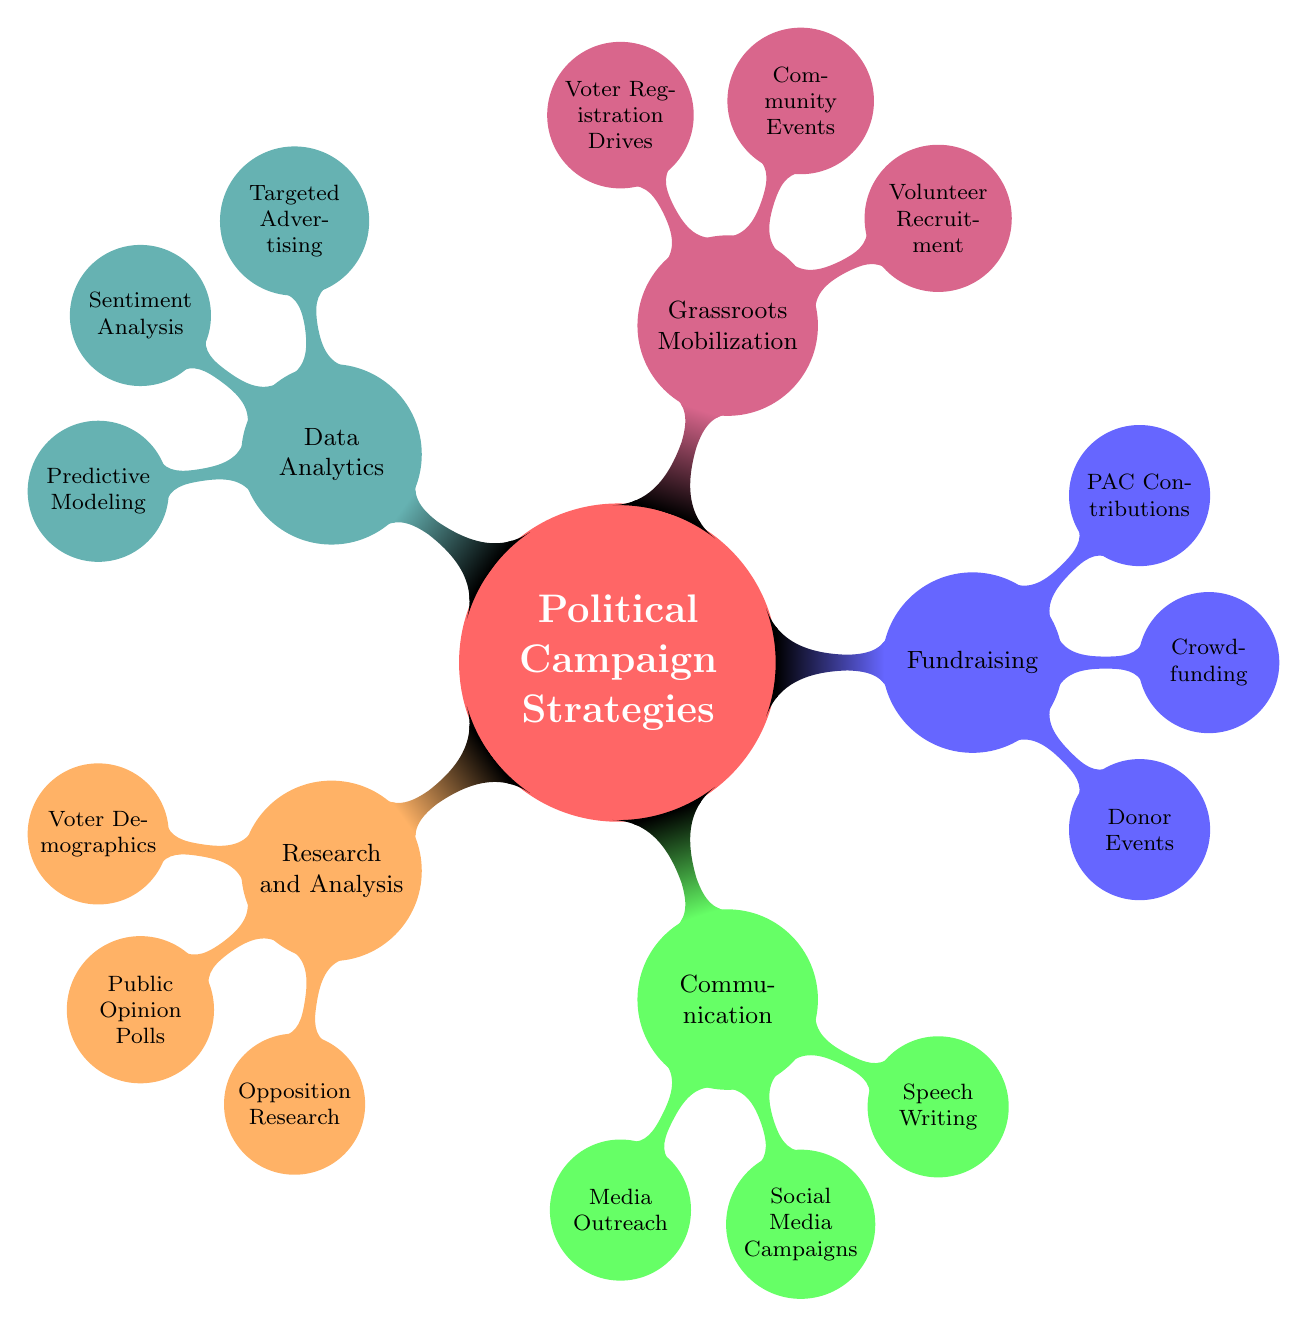What is the main category in the mind map? The main category of the mind map is identified as the central node that encompasses all other strategies. Here, it is labeled as "Political Campaign Strategies."
Answer: Political Campaign Strategies How many primary strategies are listed in the diagram? The diagram contains five main branches radiating from the central node, each representing a primary strategy including Research and Analysis, Communication, Fundraising, Grassroots Mobilization, and Data Analytics.
Answer: 5 Which strategy includes "Media Outreach"? By examining the branches, "Media Outreach" is found under the "Communication" category, as a sub-node therein.
Answer: Communication What does "Sentiment Analysis" fall under? To determine the category, we look for the parent node of "Sentiment Analysis." It is categorized under "Data Analytics" within the structure of the mind map.
Answer: Data Analytics Which strategy has the node "Voter Registration Drives"? "Voter Registration Drives" is listed as a sub-node under "Grassroots Mobilization." This requires identifying the strategy that connects to this specific action.
Answer: Grassroots Mobilization How many sub-nodes are under "Fundraising"? Counting the smaller nodes branching from "Fundraising," we find three sub-nodes: "Donor Events," "Crowdfunding," and "PAC Contributions," indicating the specific activities encompassed within fundraising efforts.
Answer: 3 What type of analysis is included in "Data Analytics"? Within "Data Analytics," three types of analysis are listed: "Targeted Advertising," "Sentiment Analysis," and "Predictive Modeling," representing different analytical approaches used in campaigns.
Answer: Targeted Advertising, Sentiment Analysis, Predictive Modeling What is one method of "Grassroots Mobilization"? Looking at the branches from "Grassroots Mobilization," one method specified is "Volunteer Recruitment," which identifies a key tactic utilized within this strategy.
Answer: Volunteer Recruitment How does "Opposition Research" contribute to campaign strategies? "Opposition Research" operates under "Research and Analysis," illustrating its critical role in understanding and potentially exploiting the weaknesses and strengths of competitors to bolster campaign effectiveness.
Answer: Research and Analysis 